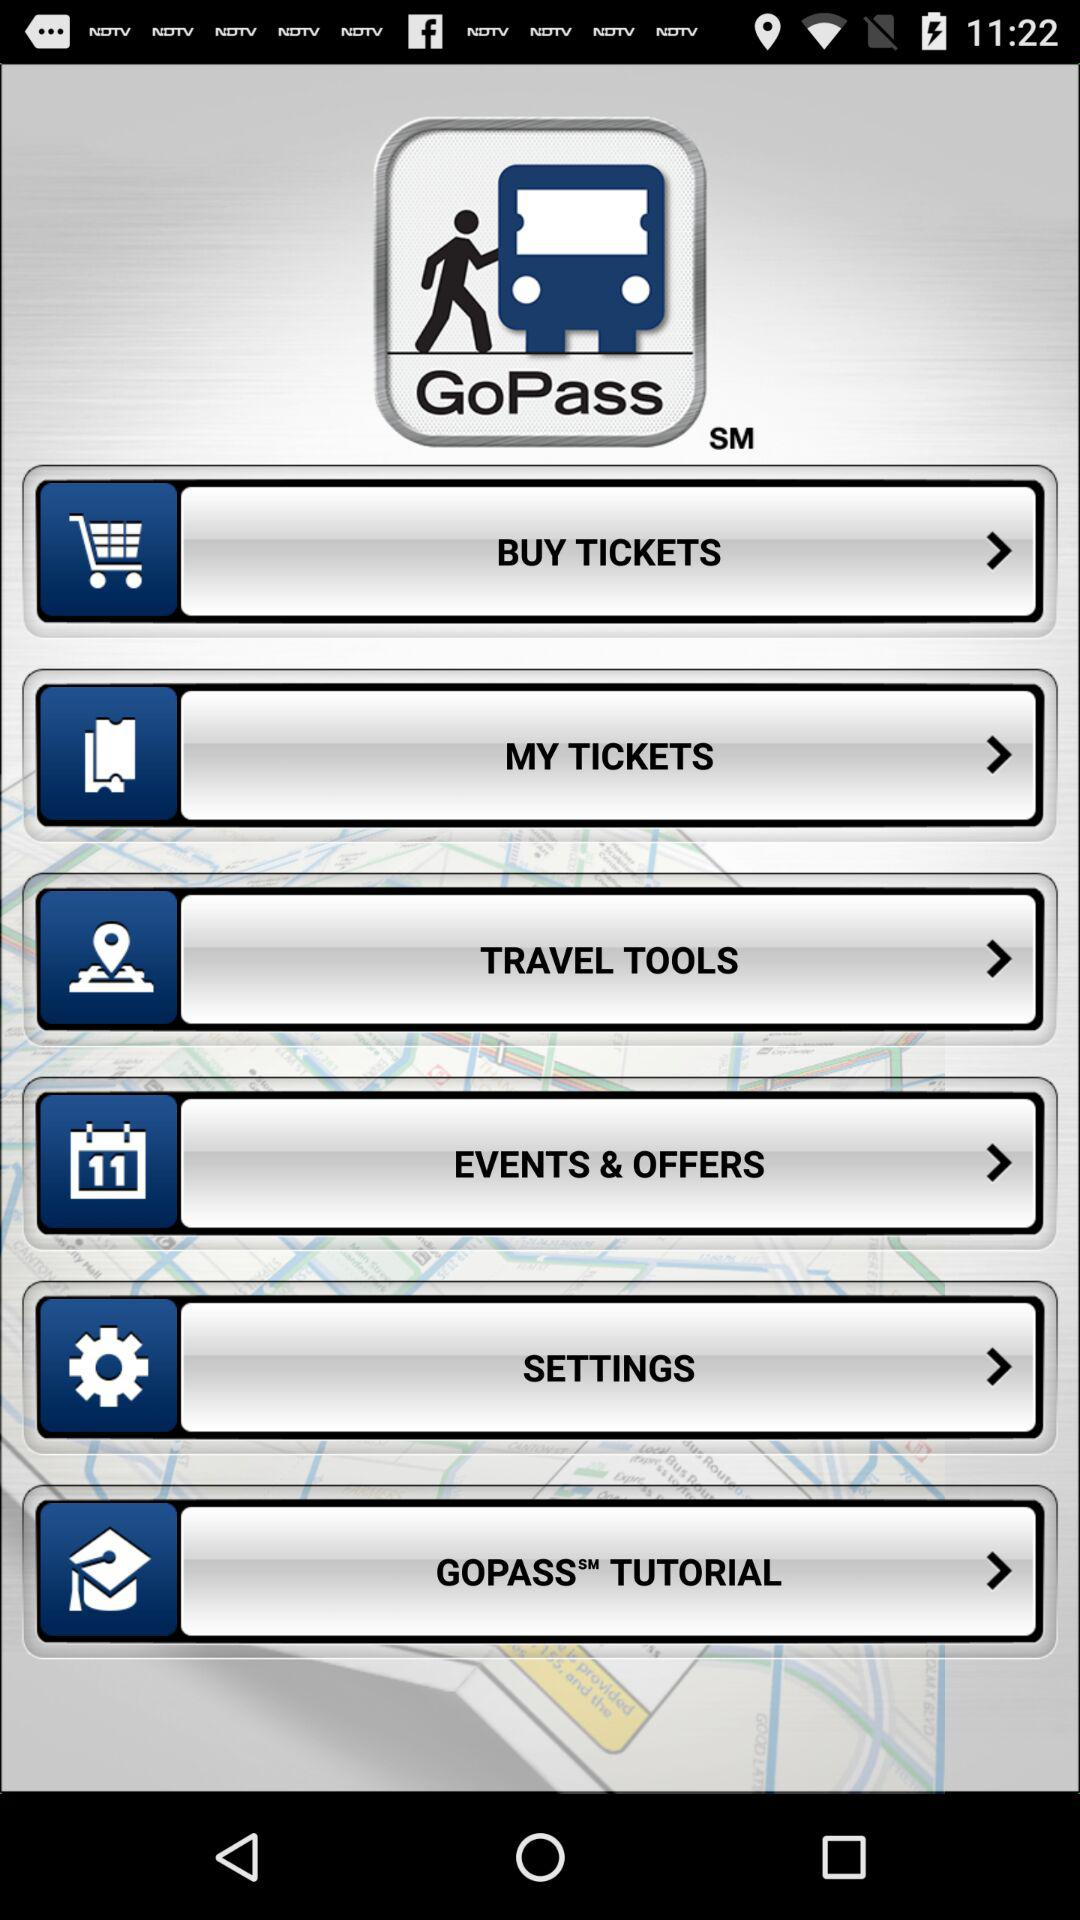What is the app name? The app name is "GoPass". 